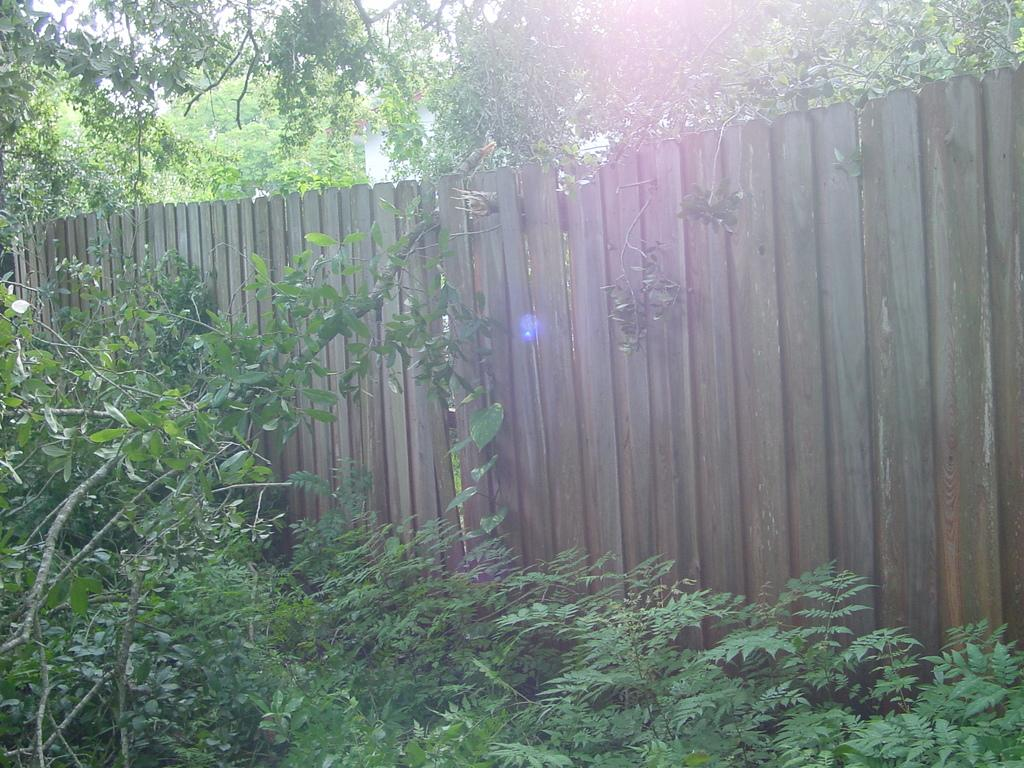What type of vegetation can be seen in the image? There are trees and plants in the image. What type of barrier is present in the image? There is a wooden fence in the image. What language is being spoken by the plants in the image? There are no plants or any form of communication present in the image. 